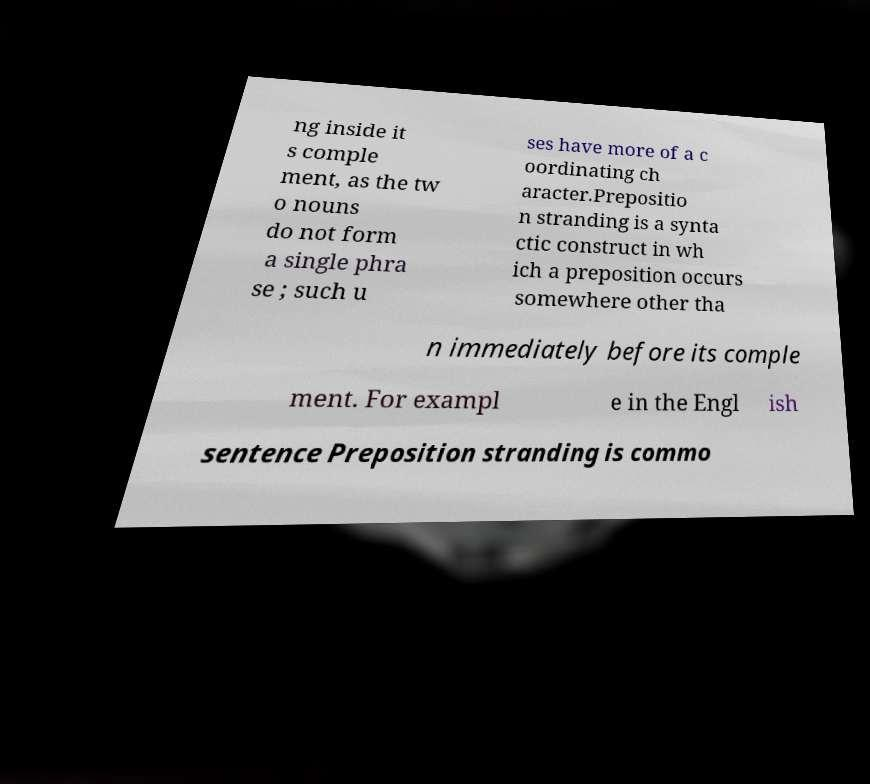Please identify and transcribe the text found in this image. ng inside it s comple ment, as the tw o nouns do not form a single phra se ; such u ses have more of a c oordinating ch aracter.Prepositio n stranding is a synta ctic construct in wh ich a preposition occurs somewhere other tha n immediately before its comple ment. For exampl e in the Engl ish sentence Preposition stranding is commo 